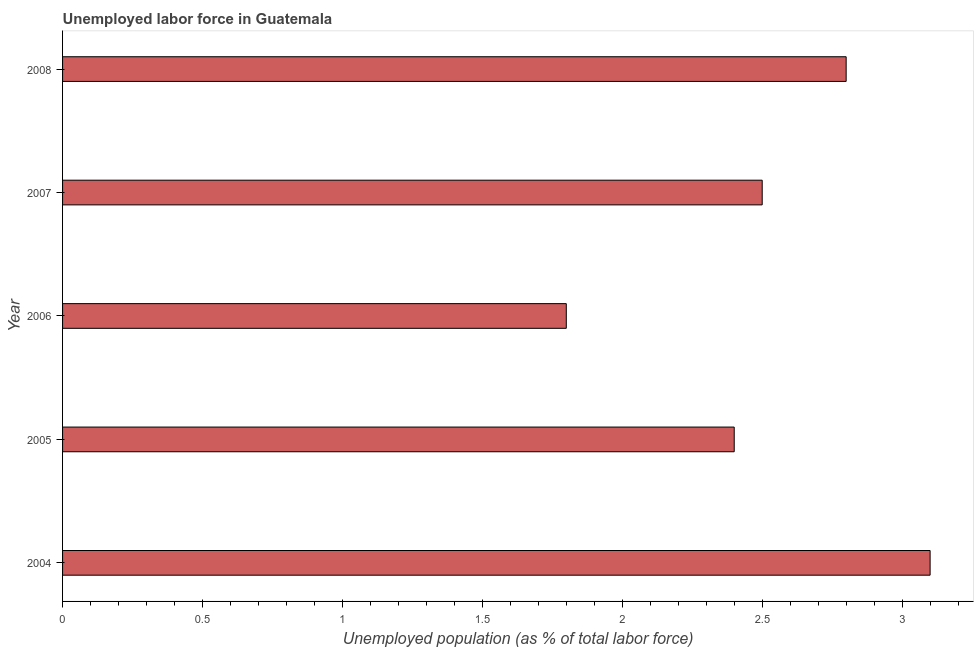Does the graph contain any zero values?
Offer a very short reply. No. What is the title of the graph?
Make the answer very short. Unemployed labor force in Guatemala. What is the label or title of the X-axis?
Your answer should be compact. Unemployed population (as % of total labor force). What is the label or title of the Y-axis?
Make the answer very short. Year. What is the total unemployed population in 2008?
Provide a short and direct response. 2.8. Across all years, what is the maximum total unemployed population?
Your answer should be compact. 3.1. Across all years, what is the minimum total unemployed population?
Your answer should be very brief. 1.8. In which year was the total unemployed population maximum?
Offer a terse response. 2004. What is the sum of the total unemployed population?
Ensure brevity in your answer.  12.6. What is the average total unemployed population per year?
Your answer should be compact. 2.52. What is the median total unemployed population?
Offer a terse response. 2.5. In how many years, is the total unemployed population greater than 0.7 %?
Provide a succinct answer. 5. What is the ratio of the total unemployed population in 2005 to that in 2006?
Ensure brevity in your answer.  1.33. Is the total unemployed population in 2007 less than that in 2008?
Ensure brevity in your answer.  Yes. Is the difference between the total unemployed population in 2005 and 2008 greater than the difference between any two years?
Your answer should be compact. No. What is the difference between the highest and the second highest total unemployed population?
Your response must be concise. 0.3. What is the difference between the highest and the lowest total unemployed population?
Your answer should be compact. 1.3. In how many years, is the total unemployed population greater than the average total unemployed population taken over all years?
Provide a short and direct response. 2. How many bars are there?
Offer a very short reply. 5. Are all the bars in the graph horizontal?
Your answer should be very brief. Yes. Are the values on the major ticks of X-axis written in scientific E-notation?
Offer a terse response. No. What is the Unemployed population (as % of total labor force) in 2004?
Make the answer very short. 3.1. What is the Unemployed population (as % of total labor force) in 2005?
Offer a terse response. 2.4. What is the Unemployed population (as % of total labor force) in 2006?
Provide a succinct answer. 1.8. What is the Unemployed population (as % of total labor force) in 2007?
Your answer should be compact. 2.5. What is the Unemployed population (as % of total labor force) of 2008?
Your answer should be very brief. 2.8. What is the difference between the Unemployed population (as % of total labor force) in 2004 and 2005?
Your answer should be very brief. 0.7. What is the difference between the Unemployed population (as % of total labor force) in 2004 and 2007?
Offer a very short reply. 0.6. What is the difference between the Unemployed population (as % of total labor force) in 2005 and 2007?
Your answer should be compact. -0.1. What is the difference between the Unemployed population (as % of total labor force) in 2006 and 2007?
Your answer should be compact. -0.7. What is the difference between the Unemployed population (as % of total labor force) in 2006 and 2008?
Keep it short and to the point. -1. What is the difference between the Unemployed population (as % of total labor force) in 2007 and 2008?
Ensure brevity in your answer.  -0.3. What is the ratio of the Unemployed population (as % of total labor force) in 2004 to that in 2005?
Offer a terse response. 1.29. What is the ratio of the Unemployed population (as % of total labor force) in 2004 to that in 2006?
Your answer should be very brief. 1.72. What is the ratio of the Unemployed population (as % of total labor force) in 2004 to that in 2007?
Offer a terse response. 1.24. What is the ratio of the Unemployed population (as % of total labor force) in 2004 to that in 2008?
Keep it short and to the point. 1.11. What is the ratio of the Unemployed population (as % of total labor force) in 2005 to that in 2006?
Make the answer very short. 1.33. What is the ratio of the Unemployed population (as % of total labor force) in 2005 to that in 2008?
Provide a succinct answer. 0.86. What is the ratio of the Unemployed population (as % of total labor force) in 2006 to that in 2007?
Offer a terse response. 0.72. What is the ratio of the Unemployed population (as % of total labor force) in 2006 to that in 2008?
Give a very brief answer. 0.64. What is the ratio of the Unemployed population (as % of total labor force) in 2007 to that in 2008?
Your answer should be compact. 0.89. 